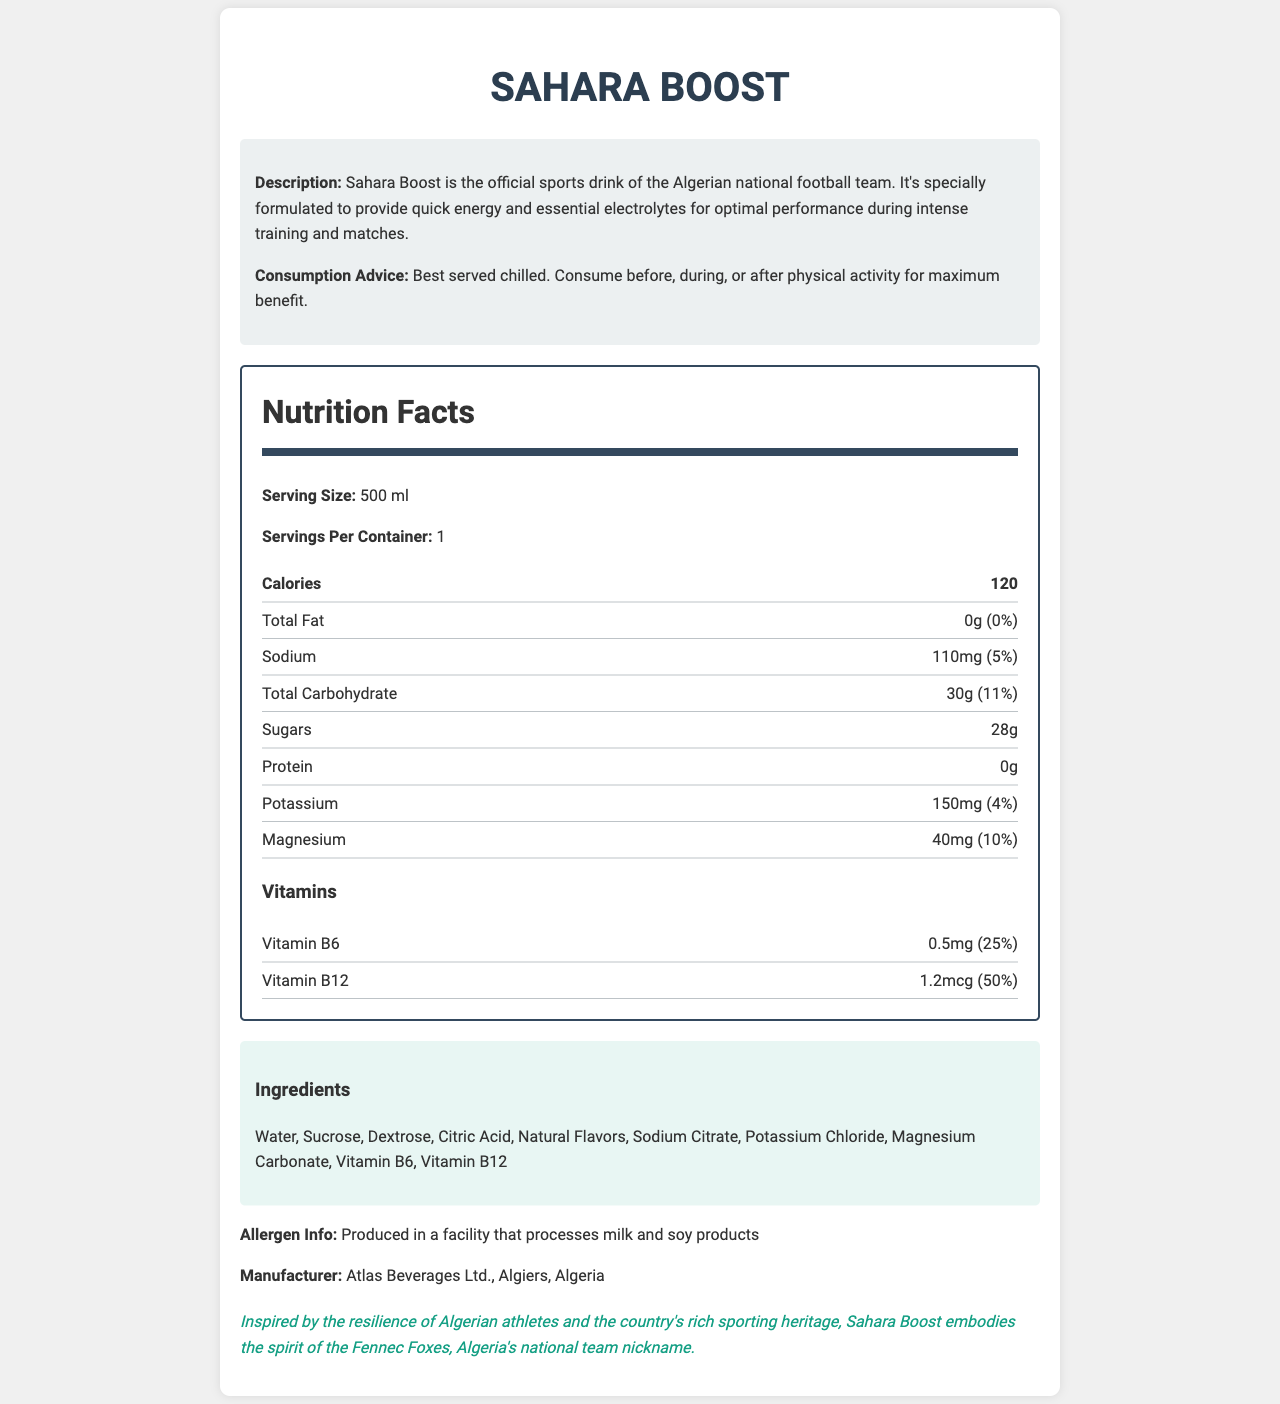what is the serving size of Sahara Boost? The serving size is listed at the beginning of the Nutrition Facts section under "Serving Size," which is 500 ml.
Answer: 500 ml How many calories are in one serving of Sahara Boost? The number of calories per serving is listed as 120 in the bold "Calories" section.
Answer: 120 What is the sodium content per serving? The sodium content per serving is given as 110 mg with a daily value of 5%.
Answer: 110 mg What is the daily value percentage for Magnesium? The magnesium content per serving is 40 mg, which corresponds to a 10% daily value.
Answer: 10% Does Sahara Boost contain any protein? The protein content is listed as 0g, indicating there is no protein in Sahara Boost.
Answer: No What is the percentage of Vitamin B6 in Sahara Boost? A. 10% B. 25% C. 50% D. 75% The document lists Vitamin B6 with an amount of 0.5 mg, which corresponds to a 25% daily value.
Answer: B. 25% Which of the following ingredients is NOT in Sahara Boost? I. Water II. Sucrose III. Whey Protein IV. Citric Acid The ingredients listed in the document do not include whey protein but do include Water, Sucrose, and Citric Acid.
Answer: III. Whey Protein Is Sahara Boost's manufacturing location in Algeria? The manufacturer information lists Atlas Beverages Ltd. located in Algiers, Algeria.
Answer: Yes Summarize the main idea of the document. The document provides a comprehensive overview of Sahara Boost, highlighting its purpose, nutritional content, ingredients, allergen information, and its connection to Algerian culture and the national football team.
Answer: Sahara Boost is a specially formulated sports drink for the Algerian national football team, designed to provide quick energy and essential electrolytes for optimal performance. The document includes detailed nutrition facts, ingredients, and manufacturer information, along with some cultural and consumption advice. Who is the target market for Sahara Boost? The document does not explicitly detail the target market for Sahara Boost, although it references the Algerian national football team.
Answer: Cannot be determined 